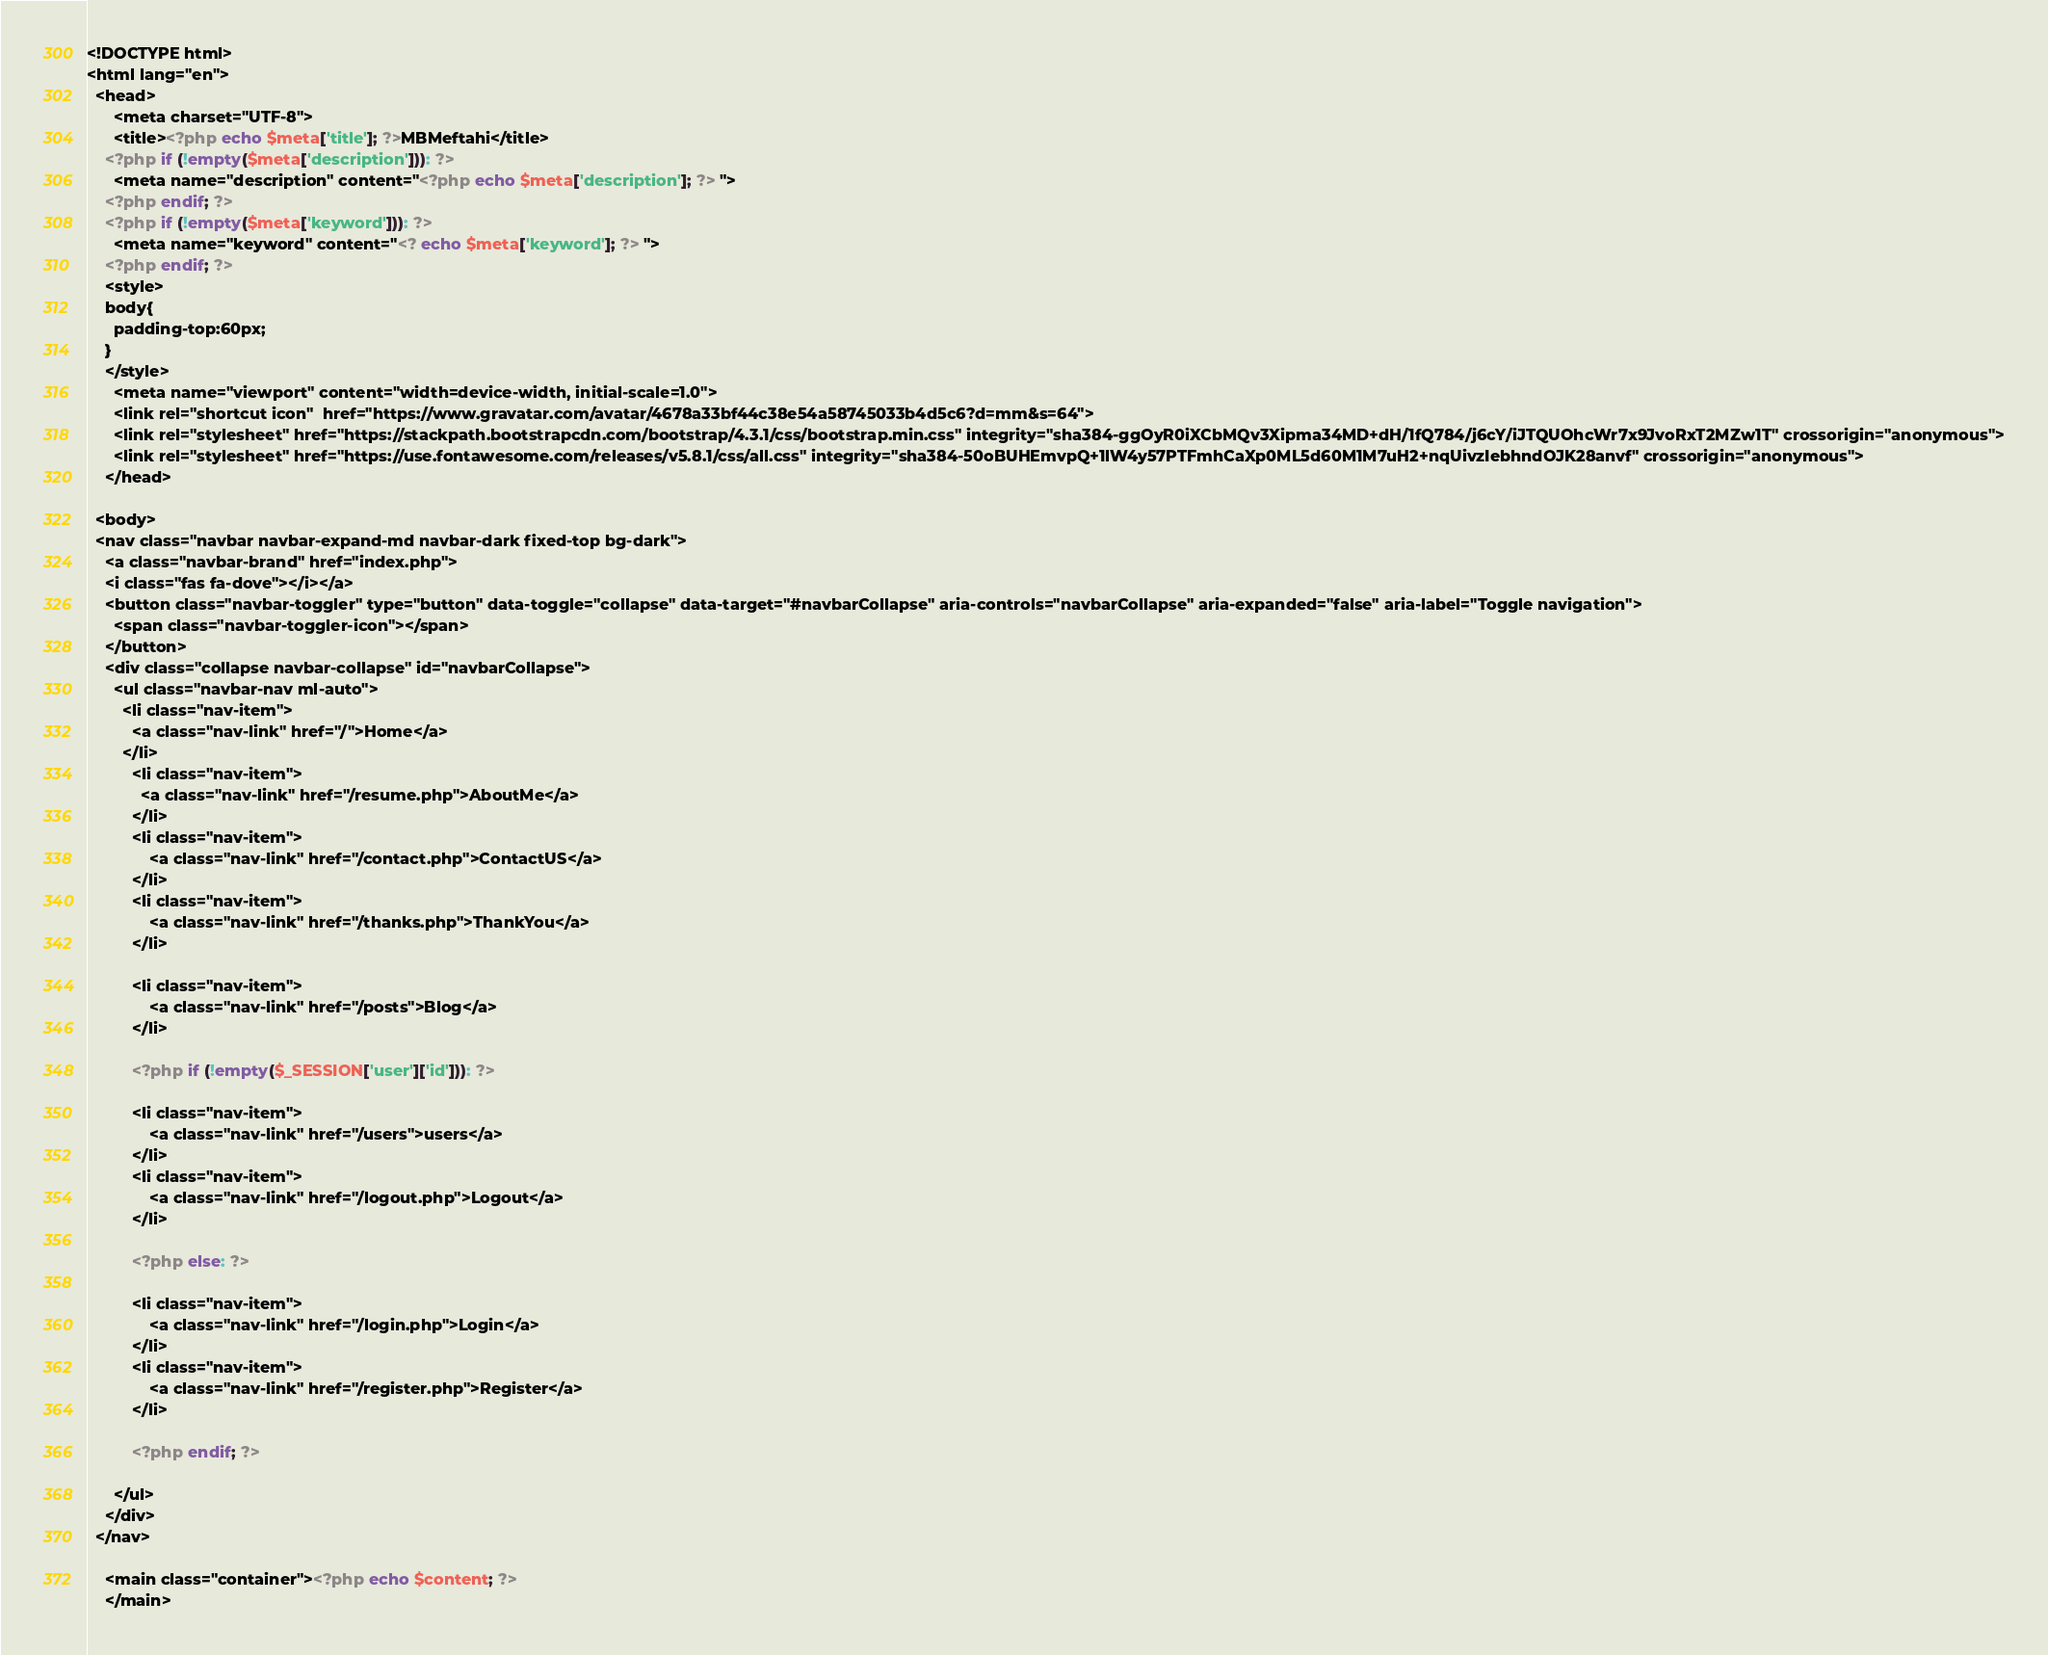<code> <loc_0><loc_0><loc_500><loc_500><_PHP_><!DOCTYPE html>
<html lang="en">
  <head>
      <meta charset="UTF-8">
      <title><?php echo $meta['title']; ?>MBMeftahi</title>
    <?php if (!empty($meta['description'])): ?>
      <meta name="description" content="<?php echo $meta['description']; ?> ">
    <?php endif; ?>
    <?php if (!empty($meta['keyword'])): ?>
      <meta name="keyword" content="<? echo $meta['keyword']; ?> ">
    <?php endif; ?>
    <style> 
    body{
      padding-top:60px;
    }
    </style>
      <meta name="viewport" content="width=device-width, initial-scale=1.0">
      <link rel="shortcut icon"  href="https://www.gravatar.com/avatar/4678a33bf44c38e54a58745033b4d5c6?d=mm&s=64">
      <link rel="stylesheet" href="https://stackpath.bootstrapcdn.com/bootstrap/4.3.1/css/bootstrap.min.css" integrity="sha384-ggOyR0iXCbMQv3Xipma34MD+dH/1fQ784/j6cY/iJTQUOhcWr7x9JvoRxT2MZw1T" crossorigin="anonymous">
      <link rel="stylesheet" href="https://use.fontawesome.com/releases/v5.8.1/css/all.css" integrity="sha384-50oBUHEmvpQ+1lW4y57PTFmhCaXp0ML5d60M1M7uH2+nqUivzIebhndOJK28anvf" crossorigin="anonymous">
    </head>

  <body>
  <nav class="navbar navbar-expand-md navbar-dark fixed-top bg-dark">
    <a class="navbar-brand" href="index.php">
    <i class="fas fa-dove"></i></a>
    <button class="navbar-toggler" type="button" data-toggle="collapse" data-target="#navbarCollapse" aria-controls="navbarCollapse" aria-expanded="false" aria-label="Toggle navigation">
      <span class="navbar-toggler-icon"></span>
    </button>
    <div class="collapse navbar-collapse" id="navbarCollapse">
      <ul class="navbar-nav ml-auto">
        <li class="nav-item">
          <a class="nav-link" href="/">Home</a>
        </li>
          <li class="nav-item">
            <a class="nav-link" href="/resume.php">AboutMe</a>
          </li>
          <li class="nav-item">
              <a class="nav-link" href="/contact.php">ContactUS</a>
          </li>
          <li class="nav-item">
              <a class="nav-link" href="/thanks.php">ThankYou</a>
          </li>

          <li class="nav-item">
              <a class="nav-link" href="/posts">Blog</a>
          </li>

          <?php if (!empty($_SESSION['user']['id'])): ?>

          <li class="nav-item">
              <a class="nav-link" href="/users">users</a>
          </li>
          <li class="nav-item">
              <a class="nav-link" href="/logout.php">Logout</a>
          </li>

          <?php else: ?>

          <li class="nav-item">
              <a class="nav-link" href="/login.php">Login</a>
          </li>
          <li class="nav-item">
              <a class="nav-link" href="/register.php">Register</a>
          </li>
          
          <?php endif; ?>

      </ul>
    </div>
  </nav>
   
    <main class="container"><?php echo $content; ?>
    </main>
</code> 